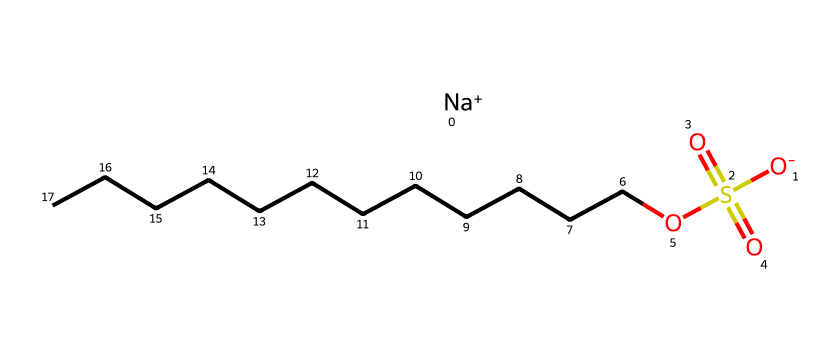What is the total number of carbon atoms in sodium dodecyl sulfate? The chemical structure shows a long hydrocarbon chain consisting of 12 carbon atoms (from "CCCCCCCCCCCC"), which is indicated in the SMILES representation.
Answer: 12 How many oxygen atoms are present in sodium dodecyl sulfate? In the chemical structure, there are 4 oxygen atoms visible: one double-bonded to sulfur and three single-bonded (one involved in the sulfate group and two in the structure).
Answer: 4 What does the "Na+" in the SMILES notation represent? The "Na+" indicates that sodium is present as a cation, which is common in ionic surfactants, providing charge balance with the anionic sulfate group.
Answer: Sodium ion Which part of sodium dodecyl sulfate gives it surfactant properties? The long hydrocarbon chain (dodecyl group) provides lipophilicity, while the sulfate group (anionic) provides hydrophilicity, enabling it to reduce surface tension.
Answer: Hydrocarbon chain and sulfate group What is the oxidation state of the sulfur in sodium dodecyl sulfate? By examining the structure, sulfur is bonded to four oxygen atoms, yielding an oxidation state of +6 due to its connectivity and bonding pattern.
Answer: +6 What type of surfactant is sodium dodecyl sulfate? Given its ionic nature, with a negatively charged sulfate group, sodium dodecyl sulfate is classified as an anionic surfactant.
Answer: Anionic surfactant 